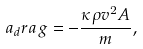Convert formula to latex. <formula><loc_0><loc_0><loc_500><loc_500>a _ { d } r a g = - \frac { \kappa \rho v ^ { 2 } A } { m } ,</formula> 